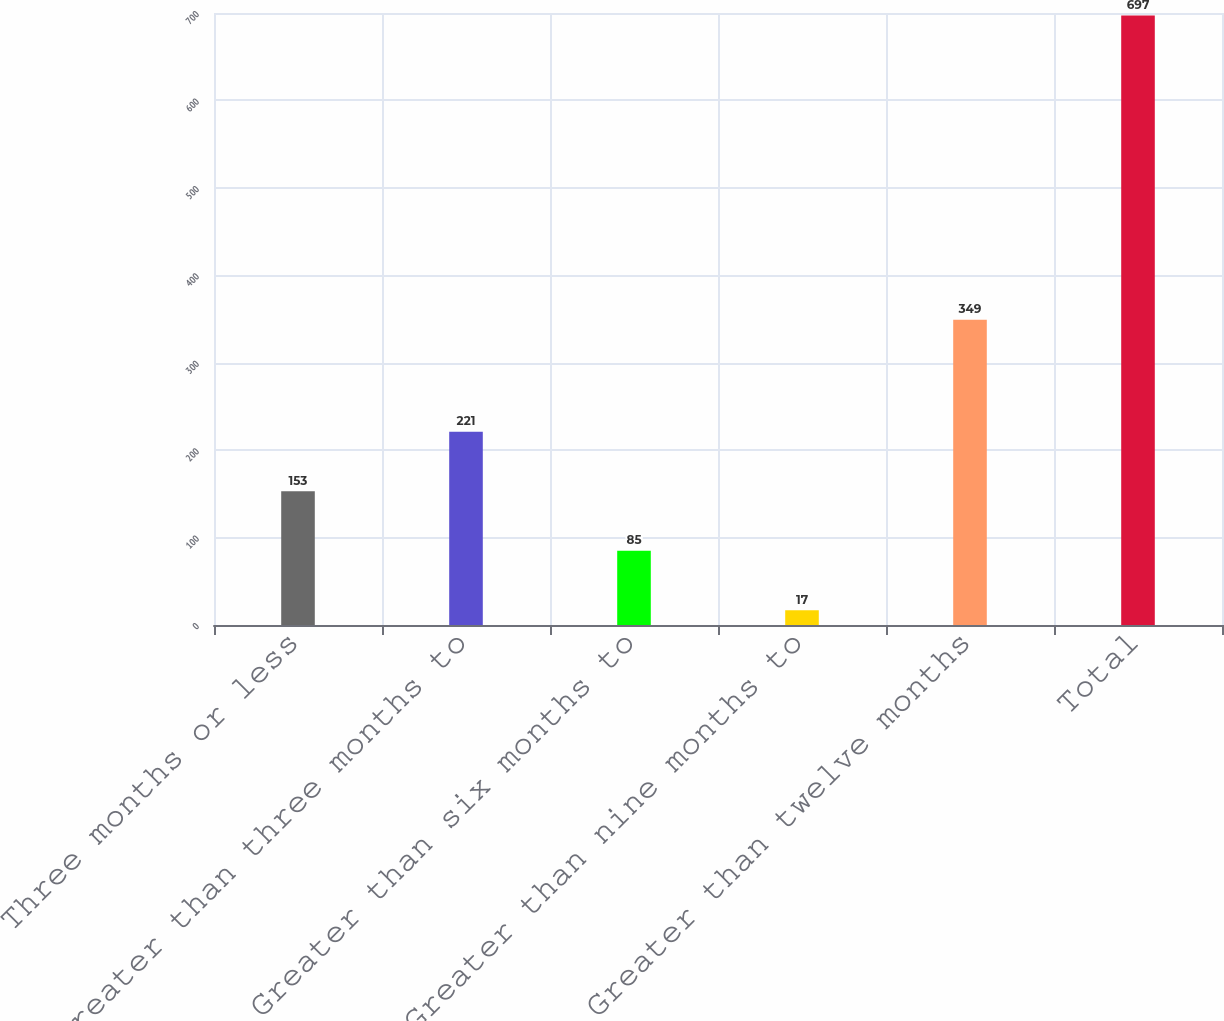Convert chart. <chart><loc_0><loc_0><loc_500><loc_500><bar_chart><fcel>Three months or less<fcel>Greater than three months to<fcel>Greater than six months to<fcel>Greater than nine months to<fcel>Greater than twelve months<fcel>Total<nl><fcel>153<fcel>221<fcel>85<fcel>17<fcel>349<fcel>697<nl></chart> 